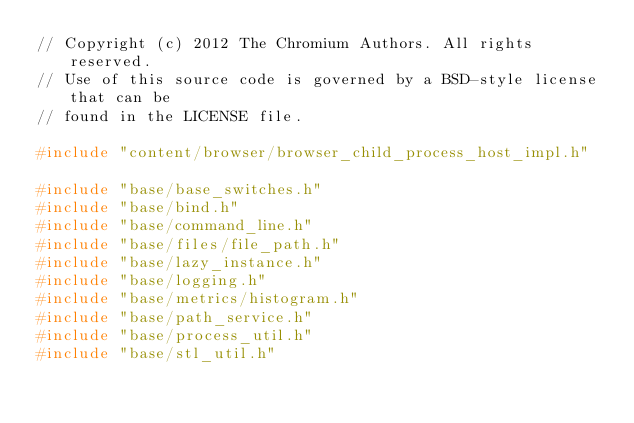Convert code to text. <code><loc_0><loc_0><loc_500><loc_500><_C++_>// Copyright (c) 2012 The Chromium Authors. All rights reserved.
// Use of this source code is governed by a BSD-style license that can be
// found in the LICENSE file.

#include "content/browser/browser_child_process_host_impl.h"

#include "base/base_switches.h"
#include "base/bind.h"
#include "base/command_line.h"
#include "base/files/file_path.h"
#include "base/lazy_instance.h"
#include "base/logging.h"
#include "base/metrics/histogram.h"
#include "base/path_service.h"
#include "base/process_util.h"
#include "base/stl_util.h"</code> 